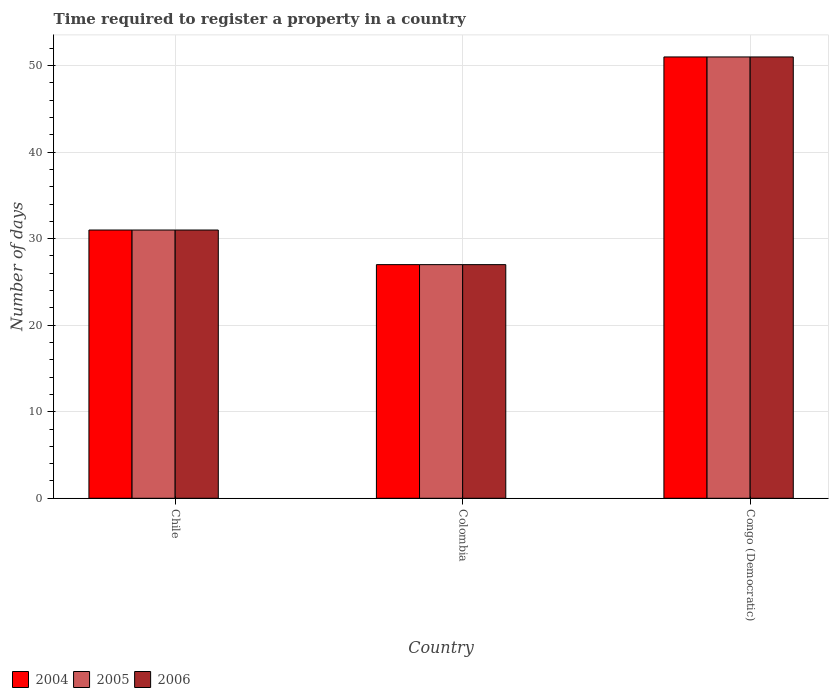How many groups of bars are there?
Give a very brief answer. 3. Are the number of bars per tick equal to the number of legend labels?
Keep it short and to the point. Yes. How many bars are there on the 2nd tick from the left?
Ensure brevity in your answer.  3. How many bars are there on the 3rd tick from the right?
Your response must be concise. 3. What is the label of the 3rd group of bars from the left?
Give a very brief answer. Congo (Democratic). In how many cases, is the number of bars for a given country not equal to the number of legend labels?
Provide a short and direct response. 0. What is the number of days required to register a property in 2006 in Congo (Democratic)?
Offer a terse response. 51. Across all countries, what is the maximum number of days required to register a property in 2004?
Give a very brief answer. 51. Across all countries, what is the minimum number of days required to register a property in 2006?
Your answer should be very brief. 27. In which country was the number of days required to register a property in 2006 maximum?
Keep it short and to the point. Congo (Democratic). In which country was the number of days required to register a property in 2004 minimum?
Your answer should be compact. Colombia. What is the total number of days required to register a property in 2005 in the graph?
Make the answer very short. 109. What is the average number of days required to register a property in 2006 per country?
Your response must be concise. 36.33. What is the difference between the number of days required to register a property of/in 2005 and number of days required to register a property of/in 2006 in Colombia?
Offer a very short reply. 0. What is the ratio of the number of days required to register a property in 2006 in Chile to that in Colombia?
Offer a very short reply. 1.15. What is the difference between the highest and the second highest number of days required to register a property in 2006?
Keep it short and to the point. -24. What is the difference between the highest and the lowest number of days required to register a property in 2004?
Your response must be concise. 24. In how many countries, is the number of days required to register a property in 2004 greater than the average number of days required to register a property in 2004 taken over all countries?
Offer a very short reply. 1. Is the sum of the number of days required to register a property in 2005 in Colombia and Congo (Democratic) greater than the maximum number of days required to register a property in 2006 across all countries?
Ensure brevity in your answer.  Yes. What does the 2nd bar from the left in Colombia represents?
Give a very brief answer. 2005. What does the 2nd bar from the right in Colombia represents?
Your response must be concise. 2005. Is it the case that in every country, the sum of the number of days required to register a property in 2004 and number of days required to register a property in 2005 is greater than the number of days required to register a property in 2006?
Give a very brief answer. Yes. Are all the bars in the graph horizontal?
Offer a terse response. No. What is the difference between two consecutive major ticks on the Y-axis?
Provide a short and direct response. 10. Does the graph contain grids?
Offer a terse response. Yes. How many legend labels are there?
Offer a very short reply. 3. What is the title of the graph?
Give a very brief answer. Time required to register a property in a country. What is the label or title of the Y-axis?
Your response must be concise. Number of days. What is the Number of days of 2006 in Chile?
Provide a short and direct response. 31. What is the Number of days of 2005 in Colombia?
Provide a succinct answer. 27. What is the Number of days in 2005 in Congo (Democratic)?
Make the answer very short. 51. What is the Number of days of 2006 in Congo (Democratic)?
Provide a succinct answer. 51. Across all countries, what is the maximum Number of days of 2004?
Keep it short and to the point. 51. What is the total Number of days of 2004 in the graph?
Your response must be concise. 109. What is the total Number of days in 2005 in the graph?
Your response must be concise. 109. What is the total Number of days in 2006 in the graph?
Your response must be concise. 109. What is the difference between the Number of days of 2004 in Chile and that in Colombia?
Ensure brevity in your answer.  4. What is the difference between the Number of days of 2005 in Chile and that in Colombia?
Offer a very short reply. 4. What is the difference between the Number of days in 2004 in Chile and that in Congo (Democratic)?
Your response must be concise. -20. What is the difference between the Number of days in 2004 in Colombia and that in Congo (Democratic)?
Provide a succinct answer. -24. What is the difference between the Number of days in 2004 in Chile and the Number of days in 2006 in Colombia?
Ensure brevity in your answer.  4. What is the difference between the Number of days in 2004 in Chile and the Number of days in 2005 in Congo (Democratic)?
Provide a short and direct response. -20. What is the difference between the Number of days of 2004 in Chile and the Number of days of 2006 in Congo (Democratic)?
Offer a terse response. -20. What is the average Number of days of 2004 per country?
Your answer should be compact. 36.33. What is the average Number of days of 2005 per country?
Provide a short and direct response. 36.33. What is the average Number of days in 2006 per country?
Give a very brief answer. 36.33. What is the difference between the Number of days in 2004 and Number of days in 2005 in Chile?
Provide a short and direct response. 0. What is the difference between the Number of days of 2004 and Number of days of 2006 in Chile?
Ensure brevity in your answer.  0. What is the difference between the Number of days of 2004 and Number of days of 2006 in Colombia?
Your answer should be very brief. 0. What is the difference between the Number of days in 2004 and Number of days in 2005 in Congo (Democratic)?
Provide a short and direct response. 0. What is the ratio of the Number of days of 2004 in Chile to that in Colombia?
Give a very brief answer. 1.15. What is the ratio of the Number of days in 2005 in Chile to that in Colombia?
Provide a short and direct response. 1.15. What is the ratio of the Number of days of 2006 in Chile to that in Colombia?
Your answer should be very brief. 1.15. What is the ratio of the Number of days in 2004 in Chile to that in Congo (Democratic)?
Your response must be concise. 0.61. What is the ratio of the Number of days in 2005 in Chile to that in Congo (Democratic)?
Make the answer very short. 0.61. What is the ratio of the Number of days in 2006 in Chile to that in Congo (Democratic)?
Ensure brevity in your answer.  0.61. What is the ratio of the Number of days in 2004 in Colombia to that in Congo (Democratic)?
Provide a succinct answer. 0.53. What is the ratio of the Number of days in 2005 in Colombia to that in Congo (Democratic)?
Provide a short and direct response. 0.53. What is the ratio of the Number of days of 2006 in Colombia to that in Congo (Democratic)?
Ensure brevity in your answer.  0.53. What is the difference between the highest and the second highest Number of days in 2005?
Your answer should be compact. 20. What is the difference between the highest and the lowest Number of days in 2004?
Provide a succinct answer. 24. What is the difference between the highest and the lowest Number of days in 2005?
Your answer should be very brief. 24. 